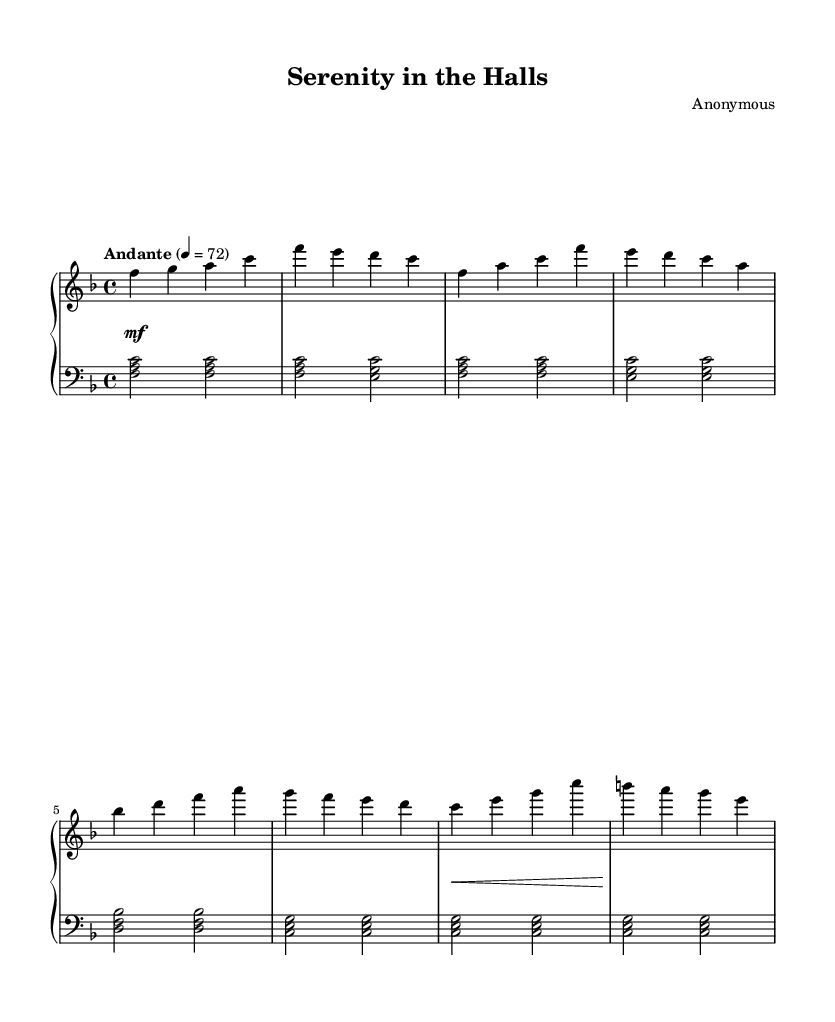What is the key signature of this music? The key signature is F major, which contains one flat (B flat). This can be determined from the beginning of the staff, where the flat symbol appears, indicating the specific notes that are altered.
Answer: F major What is the time signature of this music? The time signature is 4/4, as shown at the beginning of the score. This means there are four beats in a measure and the quarter note receives one beat.
Answer: 4/4 What is the tempo marking for this piece? The tempo marking at the start of the score indicates "Andante," which signifies a moderately slow pace. The metronome marking of 72 beats per minute provides a specific speed reference for performers.
Answer: Andante How many measures are in section A? Section A begins after the introductory measures and continues through the given musical phrases. Counting the measures in section A reveals a total of 4 measures (from the first occurrence of A leading to the end of the section).
Answer: 4 What is the dynamic marking at the beginning of the piece? The dynamic marking at the beginning shows "mf," which stands for mezzo forte, meaning moderately loud. This is indicated by the notation directly below the staff at the start of the piece.
Answer: mf What is the clef used for the left-hand part? The clef indicated for the left-hand part is bass clef. This can be seen on the left-hand staff where the bass clef symbol is marked, designating the range of notes to be played.
Answer: Bass clef Which notes are present in the left hand during the introduction? The left hand during the introduction plays the notes F, A, and C, played simultaneously as chords. This can be derived by examining the notation in the left-hand staff at the beginning.
Answer: F, A, C 